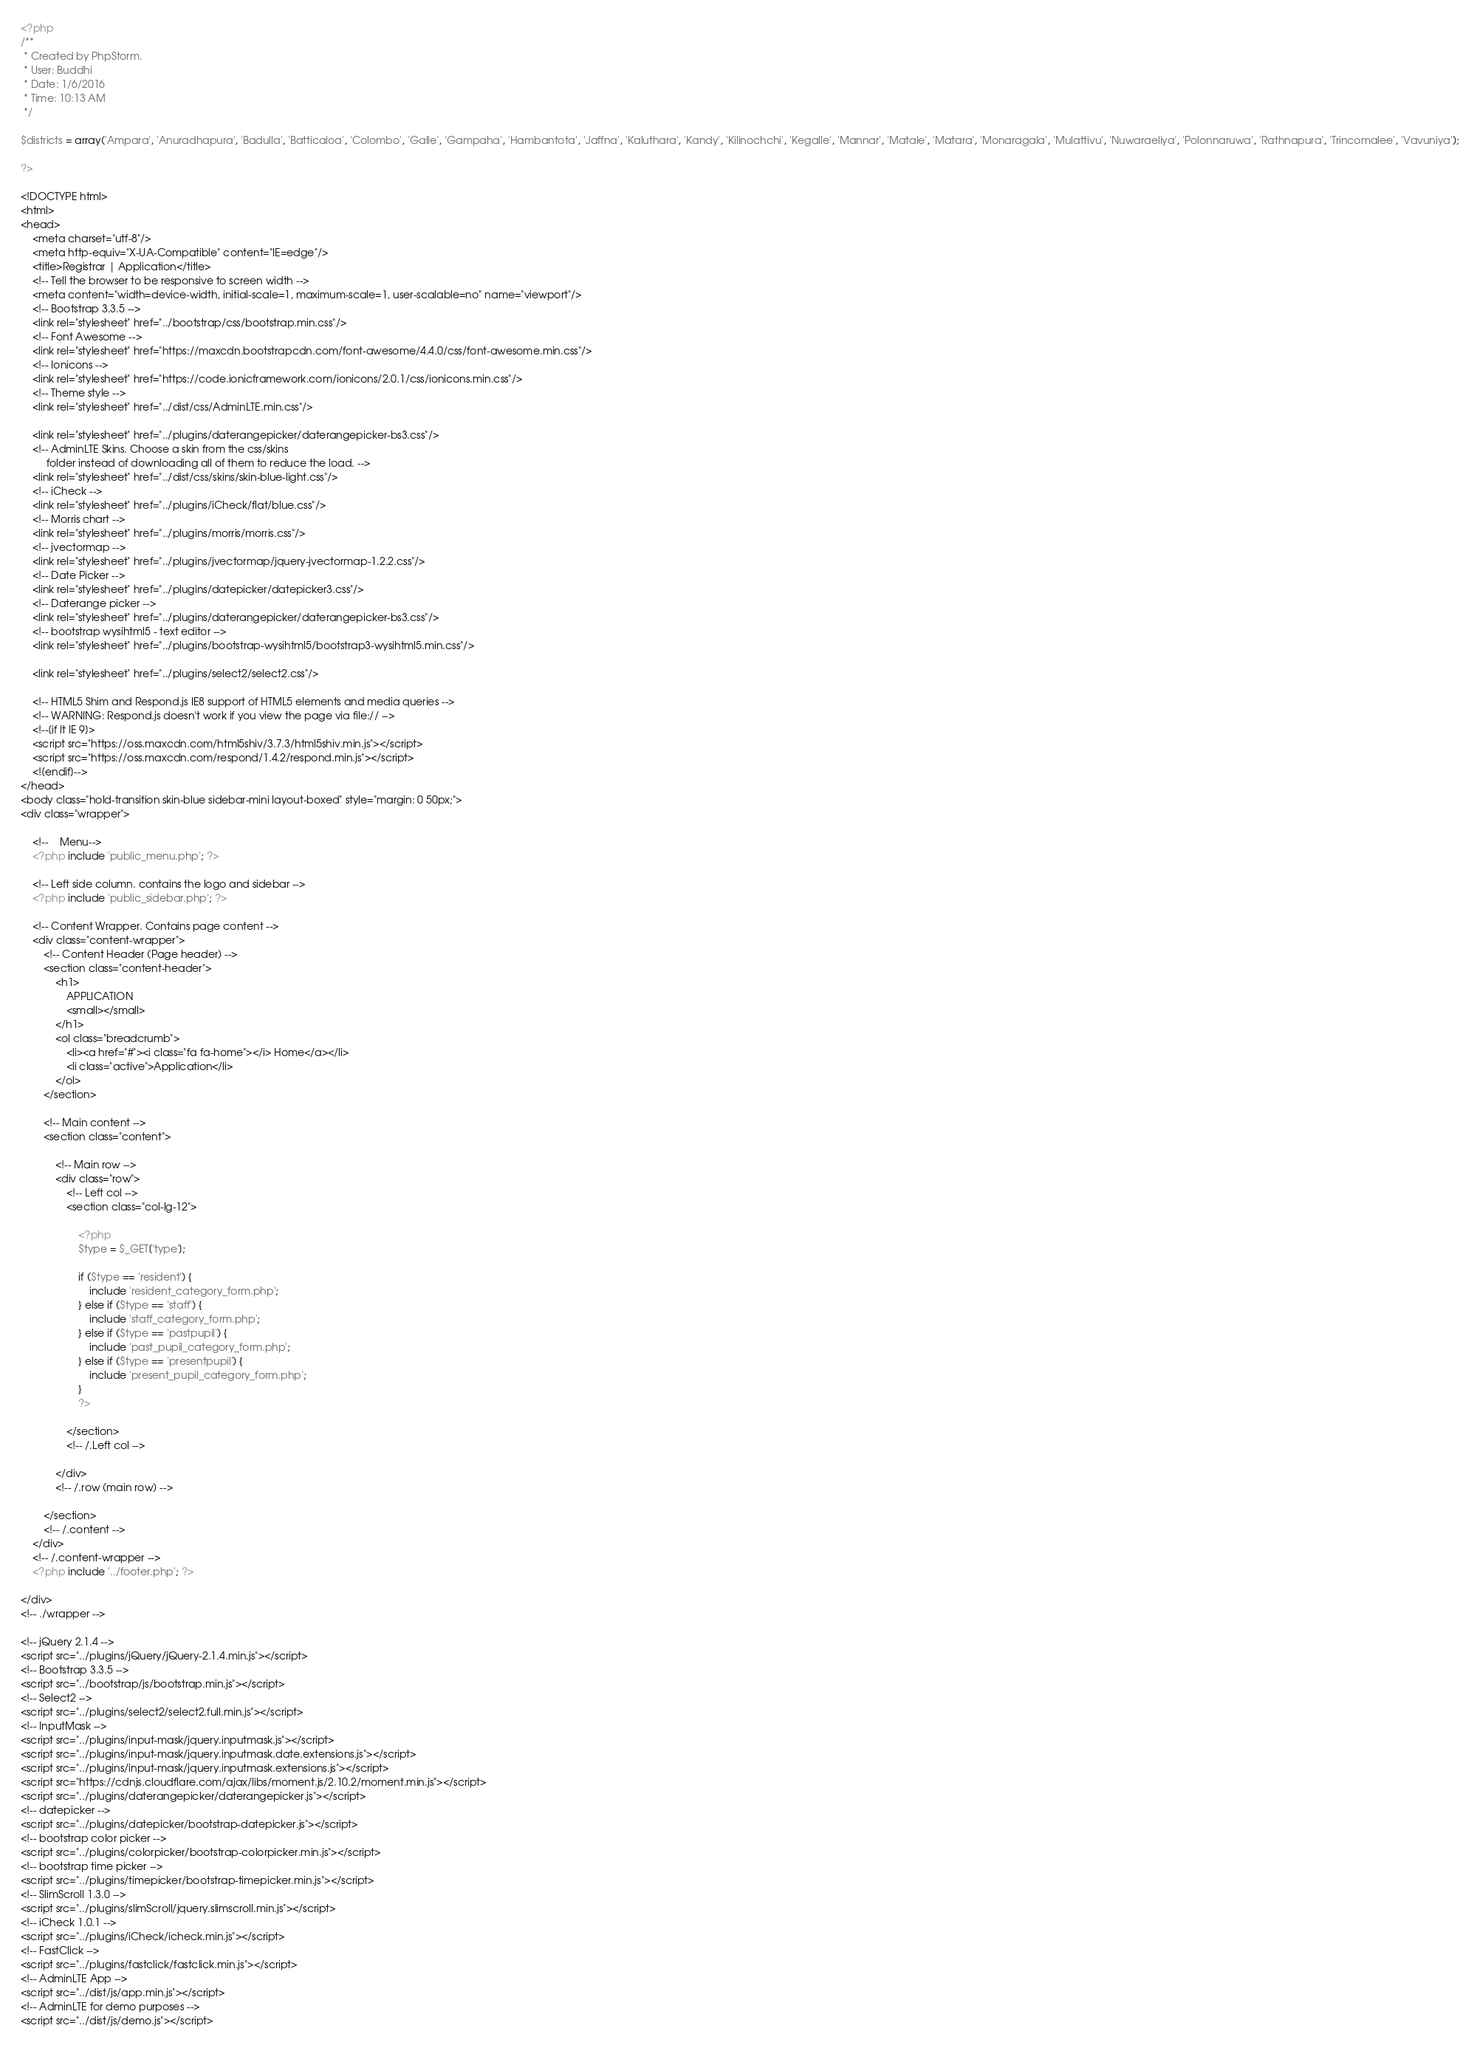<code> <loc_0><loc_0><loc_500><loc_500><_PHP_><?php
/**
 * Created by PhpStorm.
 * User: Buddhi
 * Date: 1/6/2016
 * Time: 10:13 AM
 */

$districts = array('Ampara', 'Anuradhapura', 'Badulla', 'Batticaloa', 'Colombo', 'Galle', 'Gampaha', 'Hambantota', 'Jaffna', 'Kaluthara', 'Kandy', 'Kilinochchi', 'Kegalle', 'Mannar', 'Matale', 'Matara', 'Monaragala', 'Mulattivu', 'Nuwaraeliya', 'Polonnaruwa', 'Rathnapura', 'Trincomalee', 'Vavuniya');

?>

<!DOCTYPE html>
<html>
<head>
    <meta charset="utf-8"/>
    <meta http-equiv="X-UA-Compatible" content="IE=edge"/>
    <title>Registrar | Application</title>
    <!-- Tell the browser to be responsive to screen width -->
    <meta content="width=device-width, initial-scale=1, maximum-scale=1, user-scalable=no" name="viewport"/>
    <!-- Bootstrap 3.3.5 -->
    <link rel="stylesheet" href="../bootstrap/css/bootstrap.min.css"/>
    <!-- Font Awesome -->
    <link rel="stylesheet" href="https://maxcdn.bootstrapcdn.com/font-awesome/4.4.0/css/font-awesome.min.css"/>
    <!-- Ionicons -->
    <link rel="stylesheet" href="https://code.ionicframework.com/ionicons/2.0.1/css/ionicons.min.css"/>
    <!-- Theme style -->
    <link rel="stylesheet" href="../dist/css/AdminLTE.min.css"/>

    <link rel="stylesheet" href="../plugins/daterangepicker/daterangepicker-bs3.css"/>
    <!-- AdminLTE Skins. Choose a skin from the css/skins
         folder instead of downloading all of them to reduce the load. -->
    <link rel="stylesheet" href="../dist/css/skins/skin-blue-light.css"/>
    <!-- iCheck -->
    <link rel="stylesheet" href="../plugins/iCheck/flat/blue.css"/>
    <!-- Morris chart -->
    <link rel="stylesheet" href="../plugins/morris/morris.css"/>
    <!-- jvectormap -->
    <link rel="stylesheet" href="../plugins/jvectormap/jquery-jvectormap-1.2.2.css"/>
    <!-- Date Picker -->
    <link rel="stylesheet" href="../plugins/datepicker/datepicker3.css"/>
    <!-- Daterange picker -->
    <link rel="stylesheet" href="../plugins/daterangepicker/daterangepicker-bs3.css"/>
    <!-- bootstrap wysihtml5 - text editor -->
    <link rel="stylesheet" href="../plugins/bootstrap-wysihtml5/bootstrap3-wysihtml5.min.css"/>

    <link rel="stylesheet" href="../plugins/select2/select2.css"/>

    <!-- HTML5 Shim and Respond.js IE8 support of HTML5 elements and media queries -->
    <!-- WARNING: Respond.js doesn't work if you view the page via file:// -->
    <!--[if lt IE 9]>
    <script src="https://oss.maxcdn.com/html5shiv/3.7.3/html5shiv.min.js"></script>
    <script src="https://oss.maxcdn.com/respond/1.4.2/respond.min.js"></script>
    <![endif]-->
</head>
<body class="hold-transition skin-blue sidebar-mini layout-boxed" style="margin: 0 50px;">
<div class="wrapper">

    <!--    Menu-->
    <?php include 'public_menu.php'; ?>

    <!-- Left side column. contains the logo and sidebar -->
    <?php include 'public_sidebar.php'; ?>

    <!-- Content Wrapper. Contains page content -->
    <div class="content-wrapper">
        <!-- Content Header (Page header) -->
        <section class="content-header">
            <h1>
                APPLICATION
                <small></small>
            </h1>
            <ol class="breadcrumb">
                <li><a href="#"><i class="fa fa-home"></i> Home</a></li>
                <li class="active">Application</li>
            </ol>
        </section>

        <!-- Main content -->
        <section class="content">

            <!-- Main row -->
            <div class="row">
                <!-- Left col -->
                <section class="col-lg-12">

                    <?php
                    $type = $_GET['type'];

                    if ($type == 'resident') {
                        include 'resident_category_form.php';
                    } else if ($type == 'staff') {
                        include 'staff_category_form.php';
                    } else if ($type == 'pastpupil') {
                        include 'past_pupil_category_form.php';
                    } else if ($type == 'presentpupil') {
                        include 'present_pupil_category_form.php';
                    }
                    ?>

                </section>
                <!-- /.Left col -->

            </div>
            <!-- /.row (main row) -->

        </section>
        <!-- /.content -->
    </div>
    <!-- /.content-wrapper -->
    <?php include '../footer.php'; ?>

</div>
<!-- ./wrapper -->

<!-- jQuery 2.1.4 -->
<script src="../plugins/jQuery/jQuery-2.1.4.min.js"></script>
<!-- Bootstrap 3.3.5 -->
<script src="../bootstrap/js/bootstrap.min.js"></script>
<!-- Select2 -->
<script src="../plugins/select2/select2.full.min.js"></script>
<!-- InputMask -->
<script src="../plugins/input-mask/jquery.inputmask.js"></script>
<script src="../plugins/input-mask/jquery.inputmask.date.extensions.js"></script>
<script src="../plugins/input-mask/jquery.inputmask.extensions.js"></script>
<script src="https://cdnjs.cloudflare.com/ajax/libs/moment.js/2.10.2/moment.min.js"></script>
<script src="../plugins/daterangepicker/daterangepicker.js"></script>
<!-- datepicker -->
<script src="../plugins/datepicker/bootstrap-datepicker.js"></script>
<!-- bootstrap color picker -->
<script src="../plugins/colorpicker/bootstrap-colorpicker.min.js"></script>
<!-- bootstrap time picker -->
<script src="../plugins/timepicker/bootstrap-timepicker.min.js"></script>
<!-- SlimScroll 1.3.0 -->
<script src="../plugins/slimScroll/jquery.slimscroll.min.js"></script>
<!-- iCheck 1.0.1 -->
<script src="../plugins/iCheck/icheck.min.js"></script>
<!-- FastClick -->
<script src="../plugins/fastclick/fastclick.min.js"></script>
<!-- AdminLTE App -->
<script src="../dist/js/app.min.js"></script>
<!-- AdminLTE for demo purposes -->
<script src="../dist/js/demo.js"></script></code> 